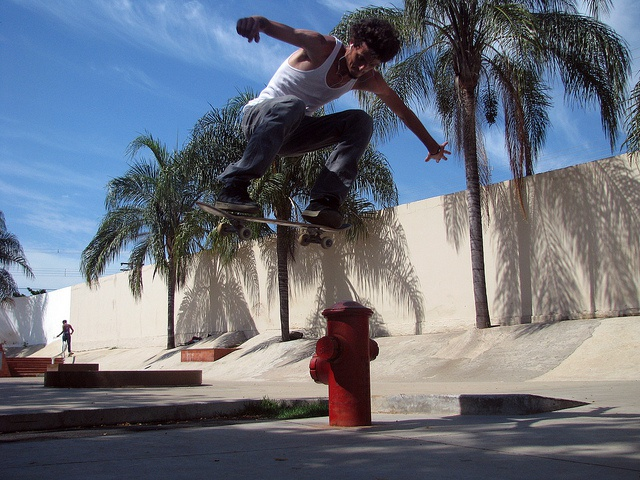Describe the objects in this image and their specific colors. I can see people in gray and black tones, fire hydrant in gray, black, maroon, and brown tones, bench in gray, black, brown, and lightgray tones, skateboard in gray and black tones, and bench in gray, maroon, and black tones in this image. 